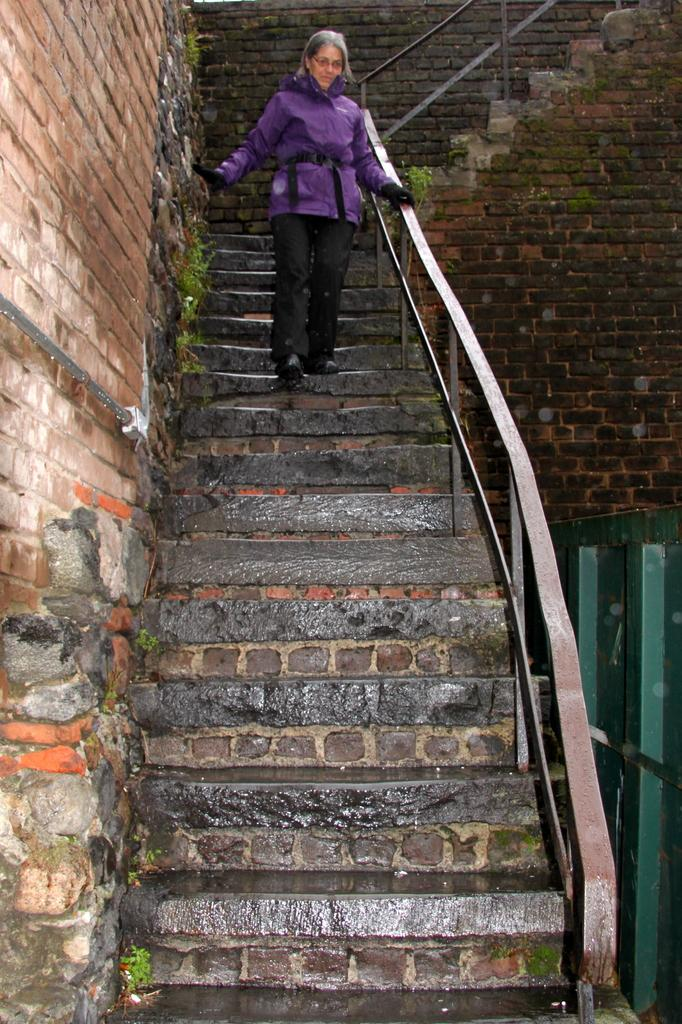What type of structure can be seen in the image? There is a wall in the image. What architectural feature is present in the image? There is a staircase in the image. Is there anyone using the staircase in the image? Yes, a person is present on the staircase. What type of material is visible on the right side of the image? There are wooden objects visible on the right side of the image. What type of bells can be heard ringing in the image? There are no bells present in the image, and therefore no sound can be heard. Can you describe the hill in the background of the image? There is no hill visible in the image; it only features a wall, a staircase, and wooden objects. 